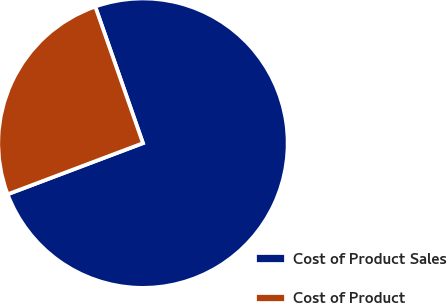<chart> <loc_0><loc_0><loc_500><loc_500><pie_chart><fcel>Cost of Product Sales<fcel>Cost of Product<nl><fcel>74.6%<fcel>25.4%<nl></chart> 